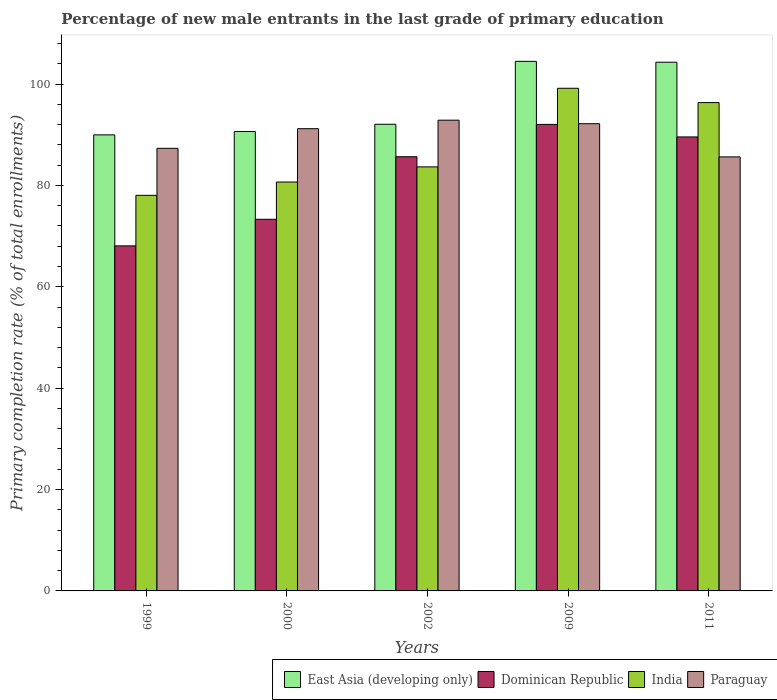How many different coloured bars are there?
Ensure brevity in your answer.  4. Are the number of bars on each tick of the X-axis equal?
Give a very brief answer. Yes. How many bars are there on the 5th tick from the left?
Provide a succinct answer. 4. What is the label of the 4th group of bars from the left?
Offer a terse response. 2009. What is the percentage of new male entrants in Dominican Republic in 2009?
Offer a very short reply. 92.04. Across all years, what is the maximum percentage of new male entrants in Paraguay?
Make the answer very short. 92.87. Across all years, what is the minimum percentage of new male entrants in Dominican Republic?
Keep it short and to the point. 68.07. What is the total percentage of new male entrants in Paraguay in the graph?
Your answer should be very brief. 449.18. What is the difference between the percentage of new male entrants in Paraguay in 2000 and that in 2009?
Ensure brevity in your answer.  -0.98. What is the difference between the percentage of new male entrants in India in 2011 and the percentage of new male entrants in Paraguay in 2009?
Make the answer very short. 4.16. What is the average percentage of new male entrants in India per year?
Make the answer very short. 87.57. In the year 2011, what is the difference between the percentage of new male entrants in Dominican Republic and percentage of new male entrants in East Asia (developing only)?
Keep it short and to the point. -14.74. What is the ratio of the percentage of new male entrants in Paraguay in 2002 to that in 2011?
Keep it short and to the point. 1.08. What is the difference between the highest and the second highest percentage of new male entrants in Paraguay?
Provide a short and direct response. 0.7. What is the difference between the highest and the lowest percentage of new male entrants in Paraguay?
Make the answer very short. 7.24. Is the sum of the percentage of new male entrants in Dominican Republic in 2000 and 2009 greater than the maximum percentage of new male entrants in India across all years?
Your response must be concise. Yes. What does the 2nd bar from the left in 2000 represents?
Your answer should be very brief. Dominican Republic. What does the 2nd bar from the right in 2000 represents?
Your answer should be compact. India. Is it the case that in every year, the sum of the percentage of new male entrants in Paraguay and percentage of new male entrants in Dominican Republic is greater than the percentage of new male entrants in India?
Ensure brevity in your answer.  Yes. How many bars are there?
Offer a terse response. 20. Does the graph contain any zero values?
Your response must be concise. No. Where does the legend appear in the graph?
Ensure brevity in your answer.  Bottom right. What is the title of the graph?
Your answer should be compact. Percentage of new male entrants in the last grade of primary education. Does "Bolivia" appear as one of the legend labels in the graph?
Your answer should be compact. No. What is the label or title of the Y-axis?
Provide a short and direct response. Primary completion rate (% of total enrollments). What is the Primary completion rate (% of total enrollments) of East Asia (developing only) in 1999?
Keep it short and to the point. 89.97. What is the Primary completion rate (% of total enrollments) in Dominican Republic in 1999?
Ensure brevity in your answer.  68.07. What is the Primary completion rate (% of total enrollments) of India in 1999?
Keep it short and to the point. 78.04. What is the Primary completion rate (% of total enrollments) of Paraguay in 1999?
Provide a short and direct response. 87.32. What is the Primary completion rate (% of total enrollments) in East Asia (developing only) in 2000?
Provide a short and direct response. 90.63. What is the Primary completion rate (% of total enrollments) of Dominican Republic in 2000?
Make the answer very short. 73.32. What is the Primary completion rate (% of total enrollments) of India in 2000?
Provide a short and direct response. 80.67. What is the Primary completion rate (% of total enrollments) of Paraguay in 2000?
Provide a succinct answer. 91.19. What is the Primary completion rate (% of total enrollments) in East Asia (developing only) in 2002?
Give a very brief answer. 92.06. What is the Primary completion rate (% of total enrollments) in Dominican Republic in 2002?
Your response must be concise. 85.66. What is the Primary completion rate (% of total enrollments) in India in 2002?
Keep it short and to the point. 83.66. What is the Primary completion rate (% of total enrollments) of Paraguay in 2002?
Your answer should be very brief. 92.87. What is the Primary completion rate (% of total enrollments) in East Asia (developing only) in 2009?
Ensure brevity in your answer.  104.48. What is the Primary completion rate (% of total enrollments) in Dominican Republic in 2009?
Your answer should be very brief. 92.04. What is the Primary completion rate (% of total enrollments) in India in 2009?
Ensure brevity in your answer.  99.17. What is the Primary completion rate (% of total enrollments) in Paraguay in 2009?
Provide a short and direct response. 92.17. What is the Primary completion rate (% of total enrollments) in East Asia (developing only) in 2011?
Your answer should be compact. 104.3. What is the Primary completion rate (% of total enrollments) of Dominican Republic in 2011?
Keep it short and to the point. 89.57. What is the Primary completion rate (% of total enrollments) of India in 2011?
Ensure brevity in your answer.  96.34. What is the Primary completion rate (% of total enrollments) in Paraguay in 2011?
Give a very brief answer. 85.63. Across all years, what is the maximum Primary completion rate (% of total enrollments) in East Asia (developing only)?
Make the answer very short. 104.48. Across all years, what is the maximum Primary completion rate (% of total enrollments) of Dominican Republic?
Offer a very short reply. 92.04. Across all years, what is the maximum Primary completion rate (% of total enrollments) in India?
Provide a succinct answer. 99.17. Across all years, what is the maximum Primary completion rate (% of total enrollments) of Paraguay?
Ensure brevity in your answer.  92.87. Across all years, what is the minimum Primary completion rate (% of total enrollments) of East Asia (developing only)?
Your response must be concise. 89.97. Across all years, what is the minimum Primary completion rate (% of total enrollments) in Dominican Republic?
Keep it short and to the point. 68.07. Across all years, what is the minimum Primary completion rate (% of total enrollments) of India?
Provide a short and direct response. 78.04. Across all years, what is the minimum Primary completion rate (% of total enrollments) of Paraguay?
Your answer should be very brief. 85.63. What is the total Primary completion rate (% of total enrollments) of East Asia (developing only) in the graph?
Give a very brief answer. 481.45. What is the total Primary completion rate (% of total enrollments) in Dominican Republic in the graph?
Keep it short and to the point. 408.65. What is the total Primary completion rate (% of total enrollments) of India in the graph?
Provide a succinct answer. 437.87. What is the total Primary completion rate (% of total enrollments) in Paraguay in the graph?
Offer a terse response. 449.18. What is the difference between the Primary completion rate (% of total enrollments) of East Asia (developing only) in 1999 and that in 2000?
Provide a succinct answer. -0.66. What is the difference between the Primary completion rate (% of total enrollments) of Dominican Republic in 1999 and that in 2000?
Your answer should be compact. -5.25. What is the difference between the Primary completion rate (% of total enrollments) of India in 1999 and that in 2000?
Offer a very short reply. -2.63. What is the difference between the Primary completion rate (% of total enrollments) in Paraguay in 1999 and that in 2000?
Offer a terse response. -3.87. What is the difference between the Primary completion rate (% of total enrollments) in East Asia (developing only) in 1999 and that in 2002?
Make the answer very short. -2.09. What is the difference between the Primary completion rate (% of total enrollments) in Dominican Republic in 1999 and that in 2002?
Give a very brief answer. -17.58. What is the difference between the Primary completion rate (% of total enrollments) in India in 1999 and that in 2002?
Offer a very short reply. -5.61. What is the difference between the Primary completion rate (% of total enrollments) in Paraguay in 1999 and that in 2002?
Ensure brevity in your answer.  -5.55. What is the difference between the Primary completion rate (% of total enrollments) in East Asia (developing only) in 1999 and that in 2009?
Provide a short and direct response. -14.5. What is the difference between the Primary completion rate (% of total enrollments) of Dominican Republic in 1999 and that in 2009?
Give a very brief answer. -23.96. What is the difference between the Primary completion rate (% of total enrollments) in India in 1999 and that in 2009?
Your response must be concise. -21.12. What is the difference between the Primary completion rate (% of total enrollments) of Paraguay in 1999 and that in 2009?
Your answer should be very brief. -4.86. What is the difference between the Primary completion rate (% of total enrollments) of East Asia (developing only) in 1999 and that in 2011?
Give a very brief answer. -14.33. What is the difference between the Primary completion rate (% of total enrollments) in Dominican Republic in 1999 and that in 2011?
Provide a short and direct response. -21.49. What is the difference between the Primary completion rate (% of total enrollments) of India in 1999 and that in 2011?
Provide a succinct answer. -18.29. What is the difference between the Primary completion rate (% of total enrollments) in Paraguay in 1999 and that in 2011?
Give a very brief answer. 1.69. What is the difference between the Primary completion rate (% of total enrollments) of East Asia (developing only) in 2000 and that in 2002?
Provide a succinct answer. -1.43. What is the difference between the Primary completion rate (% of total enrollments) in Dominican Republic in 2000 and that in 2002?
Your answer should be compact. -12.34. What is the difference between the Primary completion rate (% of total enrollments) of India in 2000 and that in 2002?
Ensure brevity in your answer.  -2.99. What is the difference between the Primary completion rate (% of total enrollments) of Paraguay in 2000 and that in 2002?
Your response must be concise. -1.68. What is the difference between the Primary completion rate (% of total enrollments) of East Asia (developing only) in 2000 and that in 2009?
Provide a short and direct response. -13.84. What is the difference between the Primary completion rate (% of total enrollments) of Dominican Republic in 2000 and that in 2009?
Offer a terse response. -18.72. What is the difference between the Primary completion rate (% of total enrollments) of India in 2000 and that in 2009?
Offer a very short reply. -18.5. What is the difference between the Primary completion rate (% of total enrollments) of Paraguay in 2000 and that in 2009?
Your response must be concise. -0.98. What is the difference between the Primary completion rate (% of total enrollments) of East Asia (developing only) in 2000 and that in 2011?
Offer a very short reply. -13.67. What is the difference between the Primary completion rate (% of total enrollments) of Dominican Republic in 2000 and that in 2011?
Keep it short and to the point. -16.25. What is the difference between the Primary completion rate (% of total enrollments) in India in 2000 and that in 2011?
Your answer should be compact. -15.67. What is the difference between the Primary completion rate (% of total enrollments) of Paraguay in 2000 and that in 2011?
Provide a succinct answer. 5.56. What is the difference between the Primary completion rate (% of total enrollments) of East Asia (developing only) in 2002 and that in 2009?
Your answer should be very brief. -12.41. What is the difference between the Primary completion rate (% of total enrollments) of Dominican Republic in 2002 and that in 2009?
Provide a succinct answer. -6.38. What is the difference between the Primary completion rate (% of total enrollments) in India in 2002 and that in 2009?
Keep it short and to the point. -15.51. What is the difference between the Primary completion rate (% of total enrollments) of Paraguay in 2002 and that in 2009?
Provide a succinct answer. 0.7. What is the difference between the Primary completion rate (% of total enrollments) of East Asia (developing only) in 2002 and that in 2011?
Offer a very short reply. -12.24. What is the difference between the Primary completion rate (% of total enrollments) of Dominican Republic in 2002 and that in 2011?
Provide a short and direct response. -3.91. What is the difference between the Primary completion rate (% of total enrollments) of India in 2002 and that in 2011?
Provide a short and direct response. -12.68. What is the difference between the Primary completion rate (% of total enrollments) of Paraguay in 2002 and that in 2011?
Offer a terse response. 7.24. What is the difference between the Primary completion rate (% of total enrollments) in East Asia (developing only) in 2009 and that in 2011?
Give a very brief answer. 0.17. What is the difference between the Primary completion rate (% of total enrollments) of Dominican Republic in 2009 and that in 2011?
Offer a terse response. 2.47. What is the difference between the Primary completion rate (% of total enrollments) in India in 2009 and that in 2011?
Provide a short and direct response. 2.83. What is the difference between the Primary completion rate (% of total enrollments) in Paraguay in 2009 and that in 2011?
Provide a succinct answer. 6.55. What is the difference between the Primary completion rate (% of total enrollments) of East Asia (developing only) in 1999 and the Primary completion rate (% of total enrollments) of Dominican Republic in 2000?
Offer a terse response. 16.65. What is the difference between the Primary completion rate (% of total enrollments) of East Asia (developing only) in 1999 and the Primary completion rate (% of total enrollments) of India in 2000?
Your answer should be compact. 9.3. What is the difference between the Primary completion rate (% of total enrollments) in East Asia (developing only) in 1999 and the Primary completion rate (% of total enrollments) in Paraguay in 2000?
Keep it short and to the point. -1.22. What is the difference between the Primary completion rate (% of total enrollments) in Dominican Republic in 1999 and the Primary completion rate (% of total enrollments) in India in 2000?
Provide a short and direct response. -12.6. What is the difference between the Primary completion rate (% of total enrollments) in Dominican Republic in 1999 and the Primary completion rate (% of total enrollments) in Paraguay in 2000?
Provide a succinct answer. -23.12. What is the difference between the Primary completion rate (% of total enrollments) of India in 1999 and the Primary completion rate (% of total enrollments) of Paraguay in 2000?
Offer a very short reply. -13.15. What is the difference between the Primary completion rate (% of total enrollments) in East Asia (developing only) in 1999 and the Primary completion rate (% of total enrollments) in Dominican Republic in 2002?
Your response must be concise. 4.31. What is the difference between the Primary completion rate (% of total enrollments) in East Asia (developing only) in 1999 and the Primary completion rate (% of total enrollments) in India in 2002?
Your answer should be very brief. 6.32. What is the difference between the Primary completion rate (% of total enrollments) in East Asia (developing only) in 1999 and the Primary completion rate (% of total enrollments) in Paraguay in 2002?
Give a very brief answer. -2.9. What is the difference between the Primary completion rate (% of total enrollments) in Dominican Republic in 1999 and the Primary completion rate (% of total enrollments) in India in 2002?
Your answer should be very brief. -15.58. What is the difference between the Primary completion rate (% of total enrollments) in Dominican Republic in 1999 and the Primary completion rate (% of total enrollments) in Paraguay in 2002?
Provide a short and direct response. -24.8. What is the difference between the Primary completion rate (% of total enrollments) in India in 1999 and the Primary completion rate (% of total enrollments) in Paraguay in 2002?
Give a very brief answer. -14.83. What is the difference between the Primary completion rate (% of total enrollments) in East Asia (developing only) in 1999 and the Primary completion rate (% of total enrollments) in Dominican Republic in 2009?
Your answer should be very brief. -2.06. What is the difference between the Primary completion rate (% of total enrollments) in East Asia (developing only) in 1999 and the Primary completion rate (% of total enrollments) in India in 2009?
Your answer should be very brief. -9.19. What is the difference between the Primary completion rate (% of total enrollments) of East Asia (developing only) in 1999 and the Primary completion rate (% of total enrollments) of Paraguay in 2009?
Make the answer very short. -2.2. What is the difference between the Primary completion rate (% of total enrollments) of Dominican Republic in 1999 and the Primary completion rate (% of total enrollments) of India in 2009?
Give a very brief answer. -31.09. What is the difference between the Primary completion rate (% of total enrollments) of Dominican Republic in 1999 and the Primary completion rate (% of total enrollments) of Paraguay in 2009?
Keep it short and to the point. -24.1. What is the difference between the Primary completion rate (% of total enrollments) in India in 1999 and the Primary completion rate (% of total enrollments) in Paraguay in 2009?
Provide a succinct answer. -14.13. What is the difference between the Primary completion rate (% of total enrollments) in East Asia (developing only) in 1999 and the Primary completion rate (% of total enrollments) in Dominican Republic in 2011?
Offer a terse response. 0.41. What is the difference between the Primary completion rate (% of total enrollments) of East Asia (developing only) in 1999 and the Primary completion rate (% of total enrollments) of India in 2011?
Provide a succinct answer. -6.36. What is the difference between the Primary completion rate (% of total enrollments) of East Asia (developing only) in 1999 and the Primary completion rate (% of total enrollments) of Paraguay in 2011?
Offer a very short reply. 4.35. What is the difference between the Primary completion rate (% of total enrollments) in Dominican Republic in 1999 and the Primary completion rate (% of total enrollments) in India in 2011?
Your answer should be very brief. -28.26. What is the difference between the Primary completion rate (% of total enrollments) of Dominican Republic in 1999 and the Primary completion rate (% of total enrollments) of Paraguay in 2011?
Make the answer very short. -17.55. What is the difference between the Primary completion rate (% of total enrollments) of India in 1999 and the Primary completion rate (% of total enrollments) of Paraguay in 2011?
Provide a succinct answer. -7.58. What is the difference between the Primary completion rate (% of total enrollments) in East Asia (developing only) in 2000 and the Primary completion rate (% of total enrollments) in Dominican Republic in 2002?
Your answer should be compact. 4.97. What is the difference between the Primary completion rate (% of total enrollments) in East Asia (developing only) in 2000 and the Primary completion rate (% of total enrollments) in India in 2002?
Your answer should be very brief. 6.98. What is the difference between the Primary completion rate (% of total enrollments) of East Asia (developing only) in 2000 and the Primary completion rate (% of total enrollments) of Paraguay in 2002?
Provide a succinct answer. -2.24. What is the difference between the Primary completion rate (% of total enrollments) of Dominican Republic in 2000 and the Primary completion rate (% of total enrollments) of India in 2002?
Your answer should be very brief. -10.34. What is the difference between the Primary completion rate (% of total enrollments) in Dominican Republic in 2000 and the Primary completion rate (% of total enrollments) in Paraguay in 2002?
Provide a short and direct response. -19.55. What is the difference between the Primary completion rate (% of total enrollments) in India in 2000 and the Primary completion rate (% of total enrollments) in Paraguay in 2002?
Give a very brief answer. -12.2. What is the difference between the Primary completion rate (% of total enrollments) of East Asia (developing only) in 2000 and the Primary completion rate (% of total enrollments) of Dominican Republic in 2009?
Your answer should be compact. -1.4. What is the difference between the Primary completion rate (% of total enrollments) in East Asia (developing only) in 2000 and the Primary completion rate (% of total enrollments) in India in 2009?
Your answer should be compact. -8.53. What is the difference between the Primary completion rate (% of total enrollments) in East Asia (developing only) in 2000 and the Primary completion rate (% of total enrollments) in Paraguay in 2009?
Give a very brief answer. -1.54. What is the difference between the Primary completion rate (% of total enrollments) in Dominican Republic in 2000 and the Primary completion rate (% of total enrollments) in India in 2009?
Make the answer very short. -25.85. What is the difference between the Primary completion rate (% of total enrollments) of Dominican Republic in 2000 and the Primary completion rate (% of total enrollments) of Paraguay in 2009?
Ensure brevity in your answer.  -18.85. What is the difference between the Primary completion rate (% of total enrollments) in India in 2000 and the Primary completion rate (% of total enrollments) in Paraguay in 2009?
Ensure brevity in your answer.  -11.5. What is the difference between the Primary completion rate (% of total enrollments) of East Asia (developing only) in 2000 and the Primary completion rate (% of total enrollments) of Dominican Republic in 2011?
Your answer should be very brief. 1.07. What is the difference between the Primary completion rate (% of total enrollments) in East Asia (developing only) in 2000 and the Primary completion rate (% of total enrollments) in India in 2011?
Ensure brevity in your answer.  -5.7. What is the difference between the Primary completion rate (% of total enrollments) in East Asia (developing only) in 2000 and the Primary completion rate (% of total enrollments) in Paraguay in 2011?
Give a very brief answer. 5.01. What is the difference between the Primary completion rate (% of total enrollments) of Dominican Republic in 2000 and the Primary completion rate (% of total enrollments) of India in 2011?
Offer a very short reply. -23.02. What is the difference between the Primary completion rate (% of total enrollments) of Dominican Republic in 2000 and the Primary completion rate (% of total enrollments) of Paraguay in 2011?
Provide a succinct answer. -12.31. What is the difference between the Primary completion rate (% of total enrollments) in India in 2000 and the Primary completion rate (% of total enrollments) in Paraguay in 2011?
Offer a terse response. -4.96. What is the difference between the Primary completion rate (% of total enrollments) of East Asia (developing only) in 2002 and the Primary completion rate (% of total enrollments) of Dominican Republic in 2009?
Provide a short and direct response. 0.03. What is the difference between the Primary completion rate (% of total enrollments) of East Asia (developing only) in 2002 and the Primary completion rate (% of total enrollments) of India in 2009?
Your answer should be compact. -7.1. What is the difference between the Primary completion rate (% of total enrollments) of East Asia (developing only) in 2002 and the Primary completion rate (% of total enrollments) of Paraguay in 2009?
Give a very brief answer. -0.11. What is the difference between the Primary completion rate (% of total enrollments) in Dominican Republic in 2002 and the Primary completion rate (% of total enrollments) in India in 2009?
Your response must be concise. -13.51. What is the difference between the Primary completion rate (% of total enrollments) of Dominican Republic in 2002 and the Primary completion rate (% of total enrollments) of Paraguay in 2009?
Your response must be concise. -6.51. What is the difference between the Primary completion rate (% of total enrollments) of India in 2002 and the Primary completion rate (% of total enrollments) of Paraguay in 2009?
Keep it short and to the point. -8.52. What is the difference between the Primary completion rate (% of total enrollments) of East Asia (developing only) in 2002 and the Primary completion rate (% of total enrollments) of Dominican Republic in 2011?
Your response must be concise. 2.5. What is the difference between the Primary completion rate (% of total enrollments) in East Asia (developing only) in 2002 and the Primary completion rate (% of total enrollments) in India in 2011?
Offer a very short reply. -4.27. What is the difference between the Primary completion rate (% of total enrollments) of East Asia (developing only) in 2002 and the Primary completion rate (% of total enrollments) of Paraguay in 2011?
Provide a succinct answer. 6.44. What is the difference between the Primary completion rate (% of total enrollments) of Dominican Republic in 2002 and the Primary completion rate (% of total enrollments) of India in 2011?
Ensure brevity in your answer.  -10.68. What is the difference between the Primary completion rate (% of total enrollments) of Dominican Republic in 2002 and the Primary completion rate (% of total enrollments) of Paraguay in 2011?
Ensure brevity in your answer.  0.03. What is the difference between the Primary completion rate (% of total enrollments) of India in 2002 and the Primary completion rate (% of total enrollments) of Paraguay in 2011?
Offer a terse response. -1.97. What is the difference between the Primary completion rate (% of total enrollments) of East Asia (developing only) in 2009 and the Primary completion rate (% of total enrollments) of Dominican Republic in 2011?
Offer a terse response. 14.91. What is the difference between the Primary completion rate (% of total enrollments) of East Asia (developing only) in 2009 and the Primary completion rate (% of total enrollments) of India in 2011?
Your answer should be compact. 8.14. What is the difference between the Primary completion rate (% of total enrollments) in East Asia (developing only) in 2009 and the Primary completion rate (% of total enrollments) in Paraguay in 2011?
Offer a terse response. 18.85. What is the difference between the Primary completion rate (% of total enrollments) of Dominican Republic in 2009 and the Primary completion rate (% of total enrollments) of India in 2011?
Offer a terse response. -4.3. What is the difference between the Primary completion rate (% of total enrollments) in Dominican Republic in 2009 and the Primary completion rate (% of total enrollments) in Paraguay in 2011?
Your answer should be compact. 6.41. What is the difference between the Primary completion rate (% of total enrollments) in India in 2009 and the Primary completion rate (% of total enrollments) in Paraguay in 2011?
Make the answer very short. 13.54. What is the average Primary completion rate (% of total enrollments) in East Asia (developing only) per year?
Provide a succinct answer. 96.29. What is the average Primary completion rate (% of total enrollments) in Dominican Republic per year?
Provide a short and direct response. 81.73. What is the average Primary completion rate (% of total enrollments) in India per year?
Provide a short and direct response. 87.57. What is the average Primary completion rate (% of total enrollments) of Paraguay per year?
Provide a short and direct response. 89.84. In the year 1999, what is the difference between the Primary completion rate (% of total enrollments) of East Asia (developing only) and Primary completion rate (% of total enrollments) of Dominican Republic?
Offer a terse response. 21.9. In the year 1999, what is the difference between the Primary completion rate (% of total enrollments) of East Asia (developing only) and Primary completion rate (% of total enrollments) of India?
Make the answer very short. 11.93. In the year 1999, what is the difference between the Primary completion rate (% of total enrollments) in East Asia (developing only) and Primary completion rate (% of total enrollments) in Paraguay?
Your answer should be compact. 2.66. In the year 1999, what is the difference between the Primary completion rate (% of total enrollments) of Dominican Republic and Primary completion rate (% of total enrollments) of India?
Give a very brief answer. -9.97. In the year 1999, what is the difference between the Primary completion rate (% of total enrollments) in Dominican Republic and Primary completion rate (% of total enrollments) in Paraguay?
Ensure brevity in your answer.  -19.24. In the year 1999, what is the difference between the Primary completion rate (% of total enrollments) in India and Primary completion rate (% of total enrollments) in Paraguay?
Provide a succinct answer. -9.27. In the year 2000, what is the difference between the Primary completion rate (% of total enrollments) in East Asia (developing only) and Primary completion rate (% of total enrollments) in Dominican Republic?
Make the answer very short. 17.31. In the year 2000, what is the difference between the Primary completion rate (% of total enrollments) in East Asia (developing only) and Primary completion rate (% of total enrollments) in India?
Make the answer very short. 9.96. In the year 2000, what is the difference between the Primary completion rate (% of total enrollments) in East Asia (developing only) and Primary completion rate (% of total enrollments) in Paraguay?
Ensure brevity in your answer.  -0.56. In the year 2000, what is the difference between the Primary completion rate (% of total enrollments) in Dominican Republic and Primary completion rate (% of total enrollments) in India?
Your answer should be compact. -7.35. In the year 2000, what is the difference between the Primary completion rate (% of total enrollments) of Dominican Republic and Primary completion rate (% of total enrollments) of Paraguay?
Your answer should be compact. -17.87. In the year 2000, what is the difference between the Primary completion rate (% of total enrollments) in India and Primary completion rate (% of total enrollments) in Paraguay?
Offer a terse response. -10.52. In the year 2002, what is the difference between the Primary completion rate (% of total enrollments) of East Asia (developing only) and Primary completion rate (% of total enrollments) of Dominican Republic?
Give a very brief answer. 6.41. In the year 2002, what is the difference between the Primary completion rate (% of total enrollments) in East Asia (developing only) and Primary completion rate (% of total enrollments) in India?
Your answer should be compact. 8.41. In the year 2002, what is the difference between the Primary completion rate (% of total enrollments) of East Asia (developing only) and Primary completion rate (% of total enrollments) of Paraguay?
Give a very brief answer. -0.81. In the year 2002, what is the difference between the Primary completion rate (% of total enrollments) of Dominican Republic and Primary completion rate (% of total enrollments) of India?
Your response must be concise. 2. In the year 2002, what is the difference between the Primary completion rate (% of total enrollments) of Dominican Republic and Primary completion rate (% of total enrollments) of Paraguay?
Ensure brevity in your answer.  -7.21. In the year 2002, what is the difference between the Primary completion rate (% of total enrollments) of India and Primary completion rate (% of total enrollments) of Paraguay?
Make the answer very short. -9.21. In the year 2009, what is the difference between the Primary completion rate (% of total enrollments) of East Asia (developing only) and Primary completion rate (% of total enrollments) of Dominican Republic?
Keep it short and to the point. 12.44. In the year 2009, what is the difference between the Primary completion rate (% of total enrollments) in East Asia (developing only) and Primary completion rate (% of total enrollments) in India?
Your answer should be very brief. 5.31. In the year 2009, what is the difference between the Primary completion rate (% of total enrollments) in East Asia (developing only) and Primary completion rate (% of total enrollments) in Paraguay?
Provide a short and direct response. 12.3. In the year 2009, what is the difference between the Primary completion rate (% of total enrollments) in Dominican Republic and Primary completion rate (% of total enrollments) in India?
Ensure brevity in your answer.  -7.13. In the year 2009, what is the difference between the Primary completion rate (% of total enrollments) in Dominican Republic and Primary completion rate (% of total enrollments) in Paraguay?
Offer a very short reply. -0.14. In the year 2009, what is the difference between the Primary completion rate (% of total enrollments) in India and Primary completion rate (% of total enrollments) in Paraguay?
Offer a very short reply. 6.99. In the year 2011, what is the difference between the Primary completion rate (% of total enrollments) of East Asia (developing only) and Primary completion rate (% of total enrollments) of Dominican Republic?
Offer a terse response. 14.74. In the year 2011, what is the difference between the Primary completion rate (% of total enrollments) in East Asia (developing only) and Primary completion rate (% of total enrollments) in India?
Your response must be concise. 7.97. In the year 2011, what is the difference between the Primary completion rate (% of total enrollments) in East Asia (developing only) and Primary completion rate (% of total enrollments) in Paraguay?
Give a very brief answer. 18.67. In the year 2011, what is the difference between the Primary completion rate (% of total enrollments) of Dominican Republic and Primary completion rate (% of total enrollments) of India?
Keep it short and to the point. -6.77. In the year 2011, what is the difference between the Primary completion rate (% of total enrollments) of Dominican Republic and Primary completion rate (% of total enrollments) of Paraguay?
Provide a short and direct response. 3.94. In the year 2011, what is the difference between the Primary completion rate (% of total enrollments) of India and Primary completion rate (% of total enrollments) of Paraguay?
Provide a succinct answer. 10.71. What is the ratio of the Primary completion rate (% of total enrollments) in Dominican Republic in 1999 to that in 2000?
Offer a very short reply. 0.93. What is the ratio of the Primary completion rate (% of total enrollments) in India in 1999 to that in 2000?
Your answer should be very brief. 0.97. What is the ratio of the Primary completion rate (% of total enrollments) of Paraguay in 1999 to that in 2000?
Make the answer very short. 0.96. What is the ratio of the Primary completion rate (% of total enrollments) of East Asia (developing only) in 1999 to that in 2002?
Your answer should be very brief. 0.98. What is the ratio of the Primary completion rate (% of total enrollments) in Dominican Republic in 1999 to that in 2002?
Your response must be concise. 0.79. What is the ratio of the Primary completion rate (% of total enrollments) in India in 1999 to that in 2002?
Offer a very short reply. 0.93. What is the ratio of the Primary completion rate (% of total enrollments) of Paraguay in 1999 to that in 2002?
Make the answer very short. 0.94. What is the ratio of the Primary completion rate (% of total enrollments) of East Asia (developing only) in 1999 to that in 2009?
Provide a succinct answer. 0.86. What is the ratio of the Primary completion rate (% of total enrollments) in Dominican Republic in 1999 to that in 2009?
Ensure brevity in your answer.  0.74. What is the ratio of the Primary completion rate (% of total enrollments) in India in 1999 to that in 2009?
Make the answer very short. 0.79. What is the ratio of the Primary completion rate (% of total enrollments) of Paraguay in 1999 to that in 2009?
Provide a short and direct response. 0.95. What is the ratio of the Primary completion rate (% of total enrollments) in East Asia (developing only) in 1999 to that in 2011?
Give a very brief answer. 0.86. What is the ratio of the Primary completion rate (% of total enrollments) in Dominican Republic in 1999 to that in 2011?
Offer a terse response. 0.76. What is the ratio of the Primary completion rate (% of total enrollments) in India in 1999 to that in 2011?
Provide a succinct answer. 0.81. What is the ratio of the Primary completion rate (% of total enrollments) of Paraguay in 1999 to that in 2011?
Ensure brevity in your answer.  1.02. What is the ratio of the Primary completion rate (% of total enrollments) in East Asia (developing only) in 2000 to that in 2002?
Offer a very short reply. 0.98. What is the ratio of the Primary completion rate (% of total enrollments) in Dominican Republic in 2000 to that in 2002?
Provide a succinct answer. 0.86. What is the ratio of the Primary completion rate (% of total enrollments) of Paraguay in 2000 to that in 2002?
Offer a very short reply. 0.98. What is the ratio of the Primary completion rate (% of total enrollments) of East Asia (developing only) in 2000 to that in 2009?
Give a very brief answer. 0.87. What is the ratio of the Primary completion rate (% of total enrollments) in Dominican Republic in 2000 to that in 2009?
Your answer should be very brief. 0.8. What is the ratio of the Primary completion rate (% of total enrollments) of India in 2000 to that in 2009?
Make the answer very short. 0.81. What is the ratio of the Primary completion rate (% of total enrollments) in Paraguay in 2000 to that in 2009?
Your answer should be very brief. 0.99. What is the ratio of the Primary completion rate (% of total enrollments) in East Asia (developing only) in 2000 to that in 2011?
Give a very brief answer. 0.87. What is the ratio of the Primary completion rate (% of total enrollments) in Dominican Republic in 2000 to that in 2011?
Provide a short and direct response. 0.82. What is the ratio of the Primary completion rate (% of total enrollments) in India in 2000 to that in 2011?
Your answer should be compact. 0.84. What is the ratio of the Primary completion rate (% of total enrollments) of Paraguay in 2000 to that in 2011?
Your answer should be compact. 1.06. What is the ratio of the Primary completion rate (% of total enrollments) of East Asia (developing only) in 2002 to that in 2009?
Provide a succinct answer. 0.88. What is the ratio of the Primary completion rate (% of total enrollments) in Dominican Republic in 2002 to that in 2009?
Keep it short and to the point. 0.93. What is the ratio of the Primary completion rate (% of total enrollments) of India in 2002 to that in 2009?
Your answer should be compact. 0.84. What is the ratio of the Primary completion rate (% of total enrollments) of Paraguay in 2002 to that in 2009?
Your answer should be very brief. 1.01. What is the ratio of the Primary completion rate (% of total enrollments) in East Asia (developing only) in 2002 to that in 2011?
Offer a terse response. 0.88. What is the ratio of the Primary completion rate (% of total enrollments) in Dominican Republic in 2002 to that in 2011?
Make the answer very short. 0.96. What is the ratio of the Primary completion rate (% of total enrollments) in India in 2002 to that in 2011?
Ensure brevity in your answer.  0.87. What is the ratio of the Primary completion rate (% of total enrollments) of Paraguay in 2002 to that in 2011?
Your response must be concise. 1.08. What is the ratio of the Primary completion rate (% of total enrollments) of East Asia (developing only) in 2009 to that in 2011?
Offer a terse response. 1. What is the ratio of the Primary completion rate (% of total enrollments) in Dominican Republic in 2009 to that in 2011?
Offer a terse response. 1.03. What is the ratio of the Primary completion rate (% of total enrollments) of India in 2009 to that in 2011?
Your response must be concise. 1.03. What is the ratio of the Primary completion rate (% of total enrollments) of Paraguay in 2009 to that in 2011?
Your answer should be very brief. 1.08. What is the difference between the highest and the second highest Primary completion rate (% of total enrollments) in East Asia (developing only)?
Provide a succinct answer. 0.17. What is the difference between the highest and the second highest Primary completion rate (% of total enrollments) in Dominican Republic?
Your response must be concise. 2.47. What is the difference between the highest and the second highest Primary completion rate (% of total enrollments) of India?
Give a very brief answer. 2.83. What is the difference between the highest and the second highest Primary completion rate (% of total enrollments) in Paraguay?
Make the answer very short. 0.7. What is the difference between the highest and the lowest Primary completion rate (% of total enrollments) in East Asia (developing only)?
Make the answer very short. 14.5. What is the difference between the highest and the lowest Primary completion rate (% of total enrollments) of Dominican Republic?
Ensure brevity in your answer.  23.96. What is the difference between the highest and the lowest Primary completion rate (% of total enrollments) in India?
Give a very brief answer. 21.12. What is the difference between the highest and the lowest Primary completion rate (% of total enrollments) of Paraguay?
Offer a terse response. 7.24. 